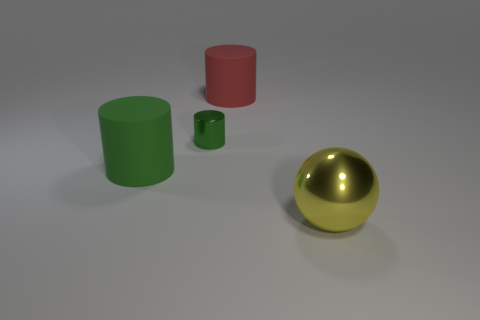Which object in the image appears to be the largest? The green cylinder looks to be the largest object in the image. 